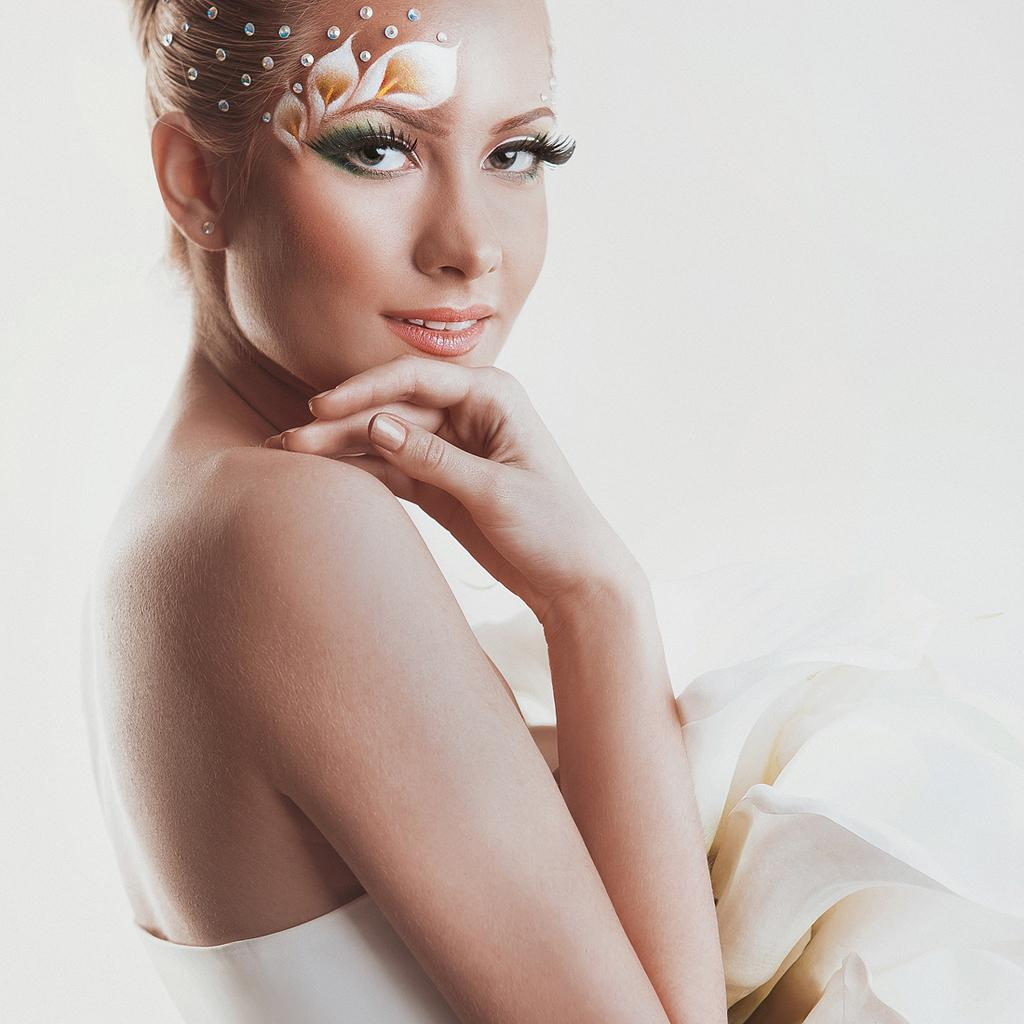Who is the main subject in the image? There is a woman in the image. What is the woman doing in the image? The woman is standing in the front, smiling, and giving a pose to the camera. What is the color of the background in the image? There is a white background in the image. What type of machine is being adjusted by the woman in the image? There is no machine present in the image, and the woman is not adjusting anything. Can you see any visible veins on the woman's hands in the image? There is no indication of visible veins on the woman's hands in the image. 